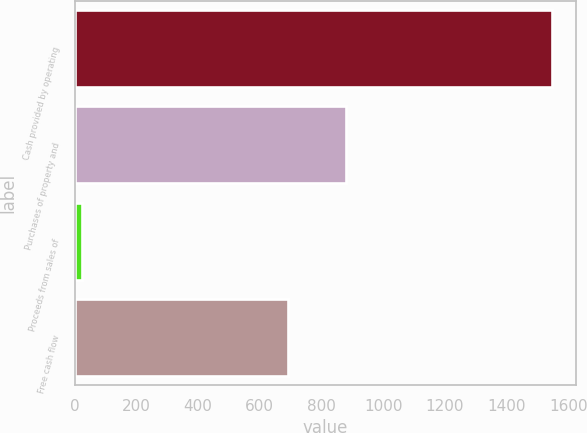Convert chart to OTSL. <chart><loc_0><loc_0><loc_500><loc_500><bar_chart><fcel>Cash provided by operating<fcel>Purchases of property and<fcel>Proceeds from sales of<fcel>Free cash flow<nl><fcel>1548.2<fcel>880.8<fcel>23.9<fcel>691.3<nl></chart> 